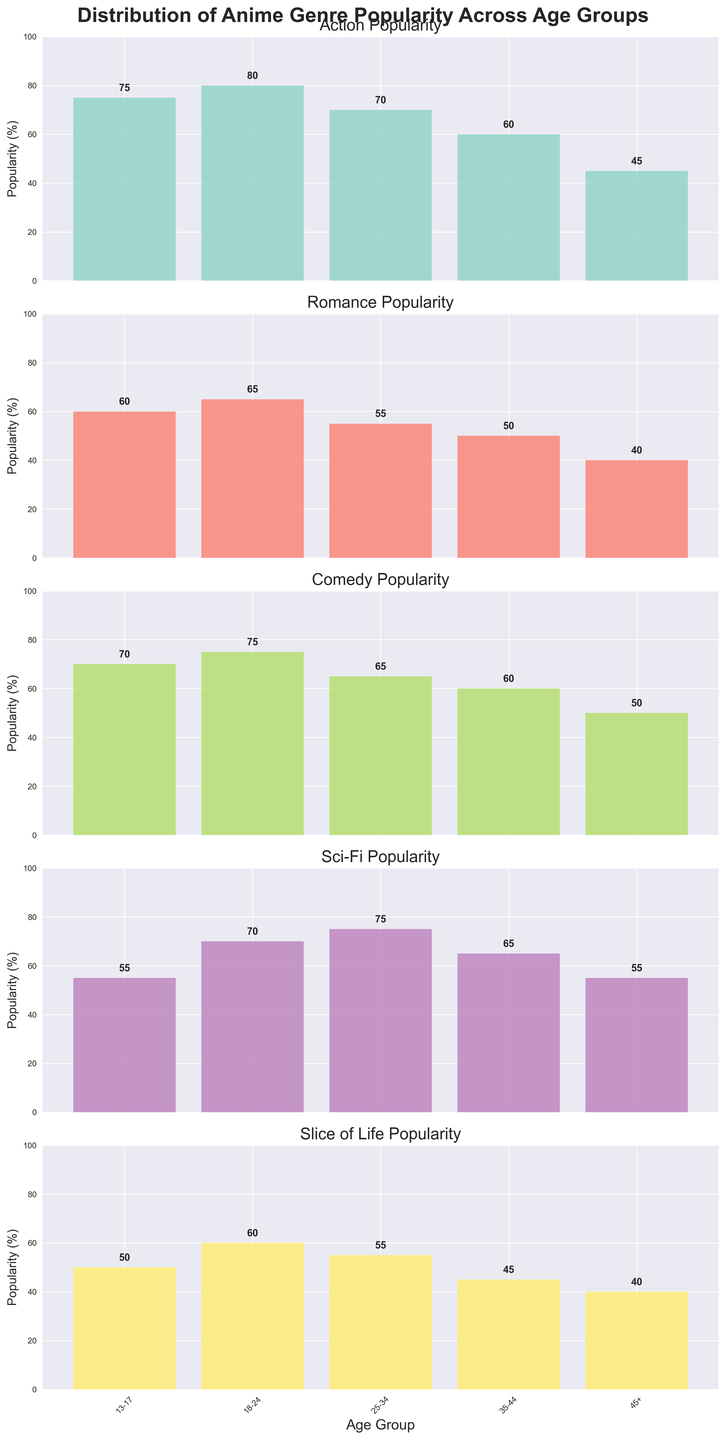What is the title of the figure? The title is displayed at the top of the figure. It is written in bold font and provides an overall description of what the figure represents.
Answer: Distribution of Anime Genre Popularity Across Age Groups Which genre is most popular in the 18-24 age group? Look at the 18-24 section and compare the heights of the bars corresponding to each genre. The Action bar is the tallest.
Answer: Action What is the least popular genre among the 45+ age group? Check the bars in the 45+ section and identify the genre with the shortest bar.
Answer: Romance How does the popularity of Sci-Fi compare between the 13-17 and 25-34 age groups? Look at the heights of the Sci-Fi bars for both age groups. Sci-Fi is more popular in the 25-34 age group (75%) compared to the 13-17 age group (55%).
Answer: More popular in the 25-34 group Calculate the average popularity of Comedy across all age groups. Add the Comedy popularity values for all age groups (70 + 75 + 65 + 60 + 50 = 320) and divide by the number of age groups (5). The average is 320/5 = 64.
Answer: 64 Which age group has the highest overall genre popularity? Sum the popularity percentages for each genre in each age group and compare the totals. The sums are: 
13-17: 75+60+70+55+50 = 310 
18-24: 80+65+75+70+60 = 350 
25-34: 70+55+65+75+55 = 320 
35-44: 60+50+60+65+45 = 280 
45+: 45+40+50+55+40 = 230 
The highest total is in the 18-24 age group.
Answer: 18-24 How does the popularity of Action change across the age groups from youngest to oldest? Observe the height of the Action bars from 13-17 to 45+. Action popularity decreases: 75, 80, 70, 60, 45.
Answer: Decreases What is the difference in popularity for Slice of Life between the youngest and oldest age groups? Subtract the Slice of Life popularity of the oldest group (45+) from the youngest group (13-17) to find the difference: 50 - 40 = 10.
Answer: 10 Identify the age group where Romance and Sci-Fi are equally popular. Check the bars for each age group and find where Romance and Sci-Fi have the same height. This is in the 35-44 age group, both at 65%.
Answer: 35-44 Which genre has the most consistent popularity across all age groups? Calculate the range (difference between maximum and minimum) of popularity for each genre across age groups and identify the genre with the smallest range:
Action: 80-45=35
Romance: 65-40=25
Comedy: 75-50=25
Sci-Fi: 75-55=20
Slice of Life: 60-40=20
Slice of Life and Sci-Fi both have the smallest range.
Answer: Slice of Life, Sci-Fi 